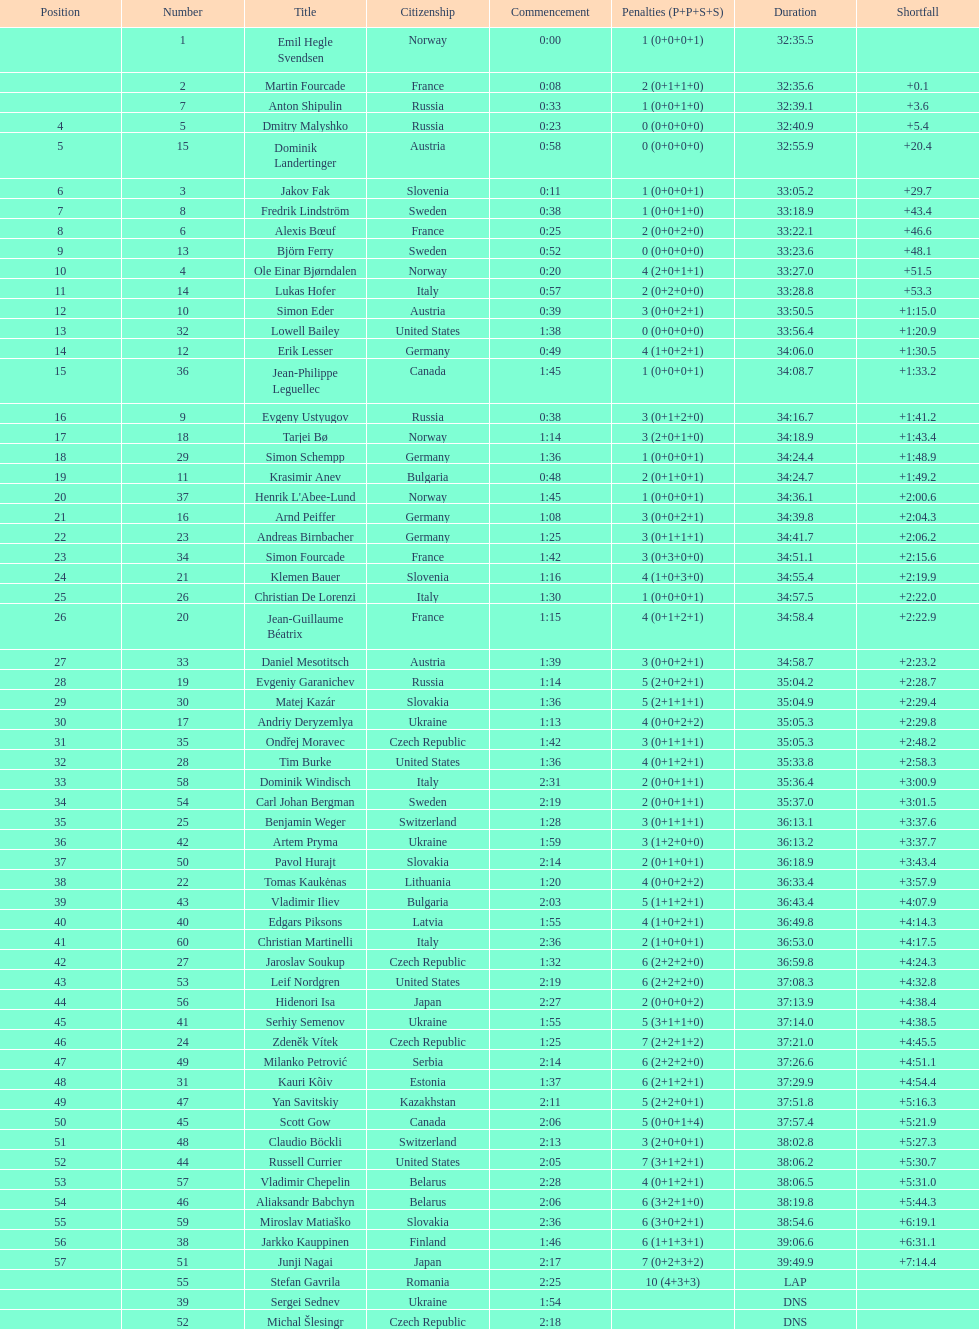What were the total number of "ties" (people who finished with the exact same time?) 2. 